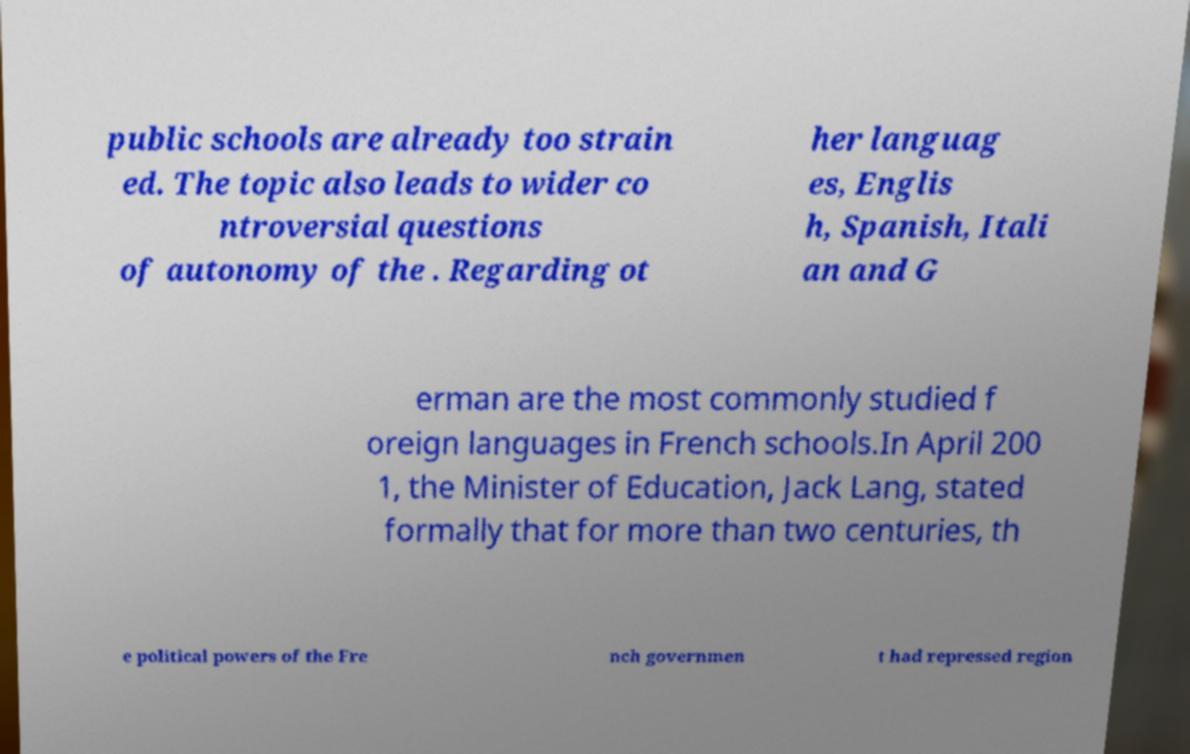What messages or text are displayed in this image? I need them in a readable, typed format. public schools are already too strain ed. The topic also leads to wider co ntroversial questions of autonomy of the . Regarding ot her languag es, Englis h, Spanish, Itali an and G erman are the most commonly studied f oreign languages in French schools.In April 200 1, the Minister of Education, Jack Lang, stated formally that for more than two centuries, th e political powers of the Fre nch governmen t had repressed region 